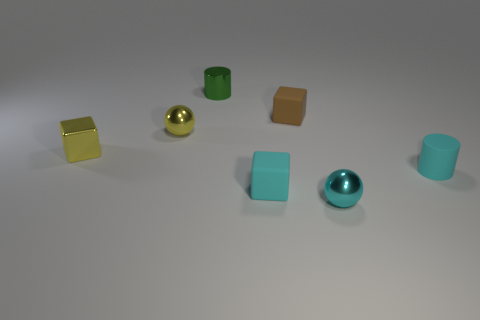How many cylinders are both behind the cyan rubber cylinder and in front of the green thing?
Offer a terse response. 0. What is the cylinder on the right side of the cyan sphere made of?
Offer a terse response. Rubber. How many metal objects have the same color as the metallic block?
Provide a short and direct response. 1. What is the size of the other ball that is made of the same material as the cyan sphere?
Your response must be concise. Small. What number of objects are tiny metallic cylinders or big things?
Make the answer very short. 1. There is a small thing that is behind the brown rubber object; what is its color?
Provide a short and direct response. Green. There is a cyan rubber object that is the same shape as the tiny green shiny object; what is its size?
Give a very brief answer. Small. What number of objects are either small cubes that are right of the tiny green metal object or tiny metallic spheres that are to the right of the tiny green metal cylinder?
Make the answer very short. 3. What is the size of the metal object that is to the left of the brown thing and in front of the yellow metal ball?
Offer a very short reply. Small. There is a tiny green object; is it the same shape as the cyan rubber object behind the tiny cyan block?
Ensure brevity in your answer.  Yes. 